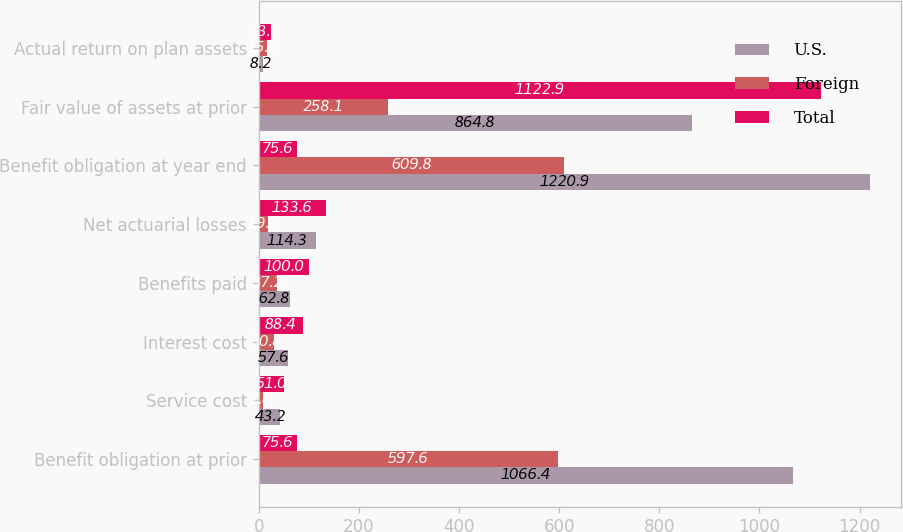Convert chart to OTSL. <chart><loc_0><loc_0><loc_500><loc_500><stacked_bar_chart><ecel><fcel>Benefit obligation at prior<fcel>Service cost<fcel>Interest cost<fcel>Benefits paid<fcel>Net actuarial losses<fcel>Benefit obligation at year end<fcel>Fair value of assets at prior<fcel>Actual return on plan assets<nl><fcel>U.S.<fcel>1066.4<fcel>43.2<fcel>57.6<fcel>62.8<fcel>114.3<fcel>1220.9<fcel>864.8<fcel>8.2<nl><fcel>Foreign<fcel>597.6<fcel>7.8<fcel>30.8<fcel>37.2<fcel>19.3<fcel>609.8<fcel>258.1<fcel>15.5<nl><fcel>Total<fcel>75.6<fcel>51<fcel>88.4<fcel>100<fcel>133.6<fcel>75.6<fcel>1122.9<fcel>23.7<nl></chart> 